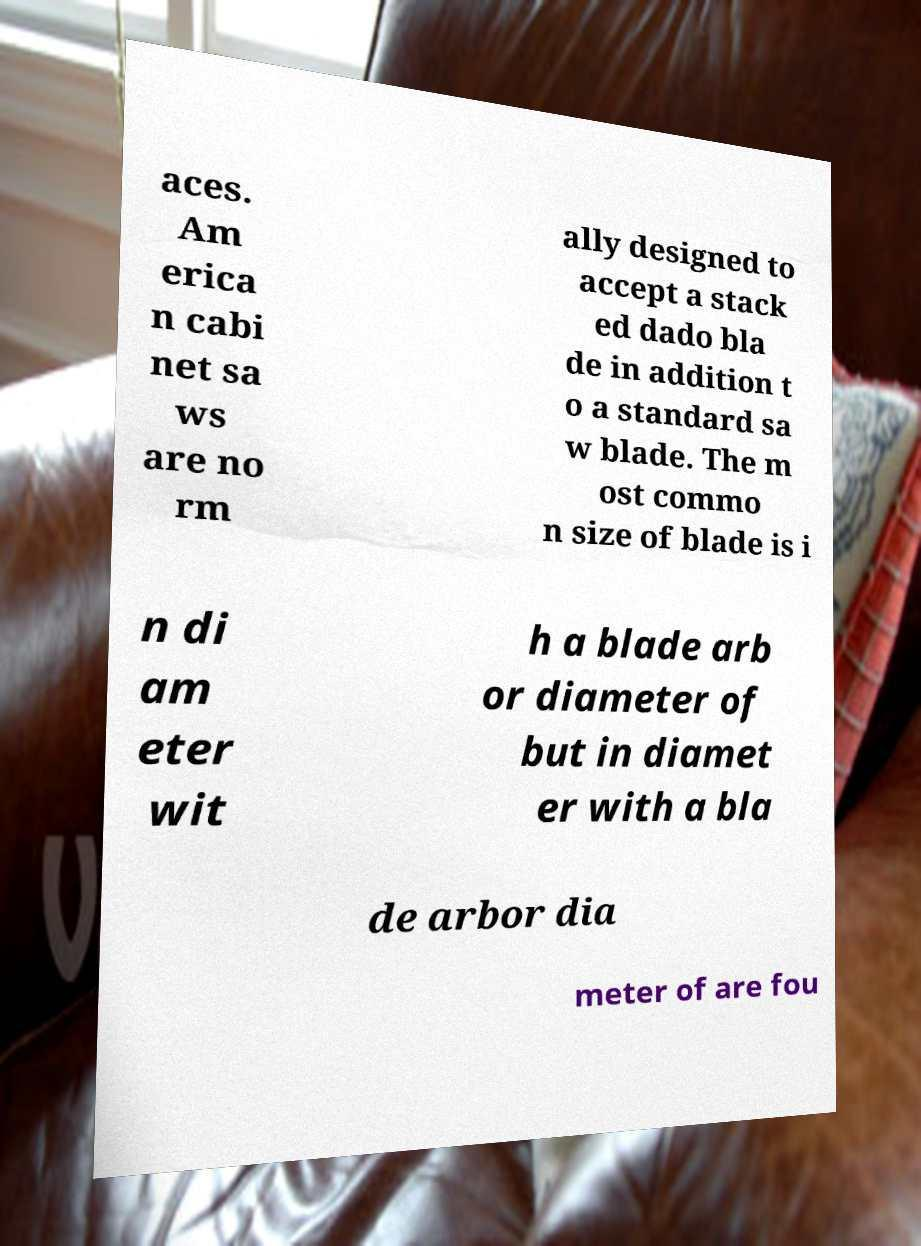Please identify and transcribe the text found in this image. aces. Am erica n cabi net sa ws are no rm ally designed to accept a stack ed dado bla de in addition t o a standard sa w blade. The m ost commo n size of blade is i n di am eter wit h a blade arb or diameter of but in diamet er with a bla de arbor dia meter of are fou 